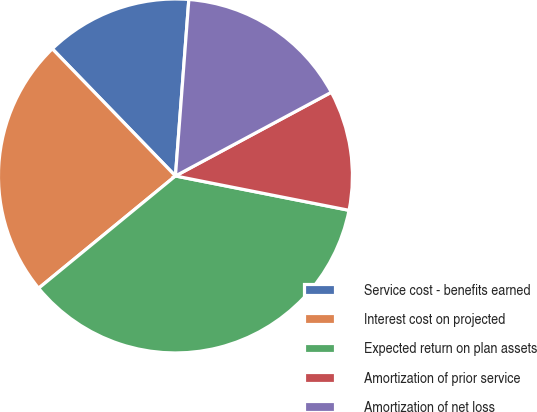Convert chart to OTSL. <chart><loc_0><loc_0><loc_500><loc_500><pie_chart><fcel>Service cost - benefits earned<fcel>Interest cost on projected<fcel>Expected return on plan assets<fcel>Amortization of prior service<fcel>Amortization of net loss<nl><fcel>13.45%<fcel>23.69%<fcel>35.95%<fcel>10.95%<fcel>15.95%<nl></chart> 